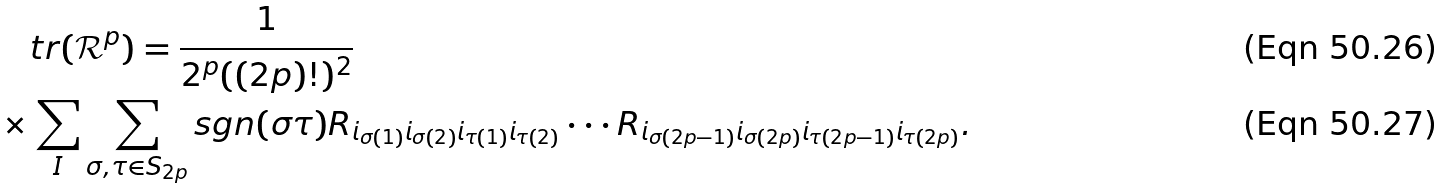<formula> <loc_0><loc_0><loc_500><loc_500>& \quad t r ( \mathcal { R } ^ { p } ) = \frac { 1 } { 2 ^ { p } ( ( 2 p ) ! ) ^ { 2 } } \\ & \times \sum _ { I } \sum _ { \sigma , \tau \in S _ { 2 p } } s g n ( \sigma \tau ) R _ { i _ { \sigma ( 1 ) } i _ { \sigma ( 2 ) } i _ { \tau ( 1 ) } i _ { \tau ( 2 ) } } \cdot \cdot \cdot R _ { i _ { \sigma ( 2 p - 1 ) } i _ { \sigma ( 2 p ) } i _ { \tau ( 2 p - 1 ) } i _ { \tau ( 2 p ) } } .</formula> 